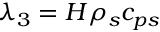<formula> <loc_0><loc_0><loc_500><loc_500>\lambda _ { 3 } = H \rho _ { s } c _ { p s }</formula> 